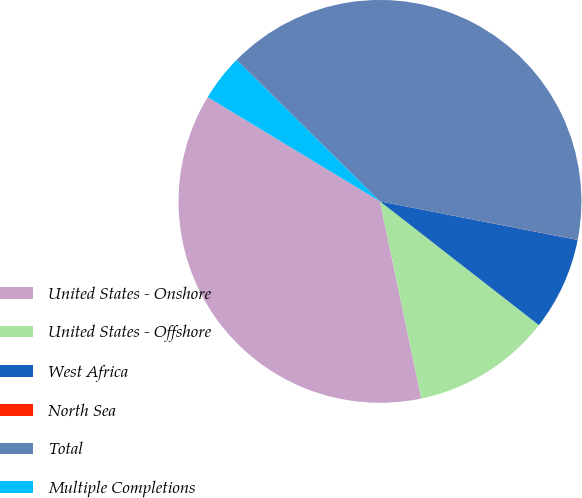Convert chart to OTSL. <chart><loc_0><loc_0><loc_500><loc_500><pie_chart><fcel>United States - Onshore<fcel>United States - Offshore<fcel>West Africa<fcel>North Sea<fcel>Total<fcel>Multiple Completions<nl><fcel>36.95%<fcel>11.18%<fcel>7.46%<fcel>0.01%<fcel>40.67%<fcel>3.73%<nl></chart> 